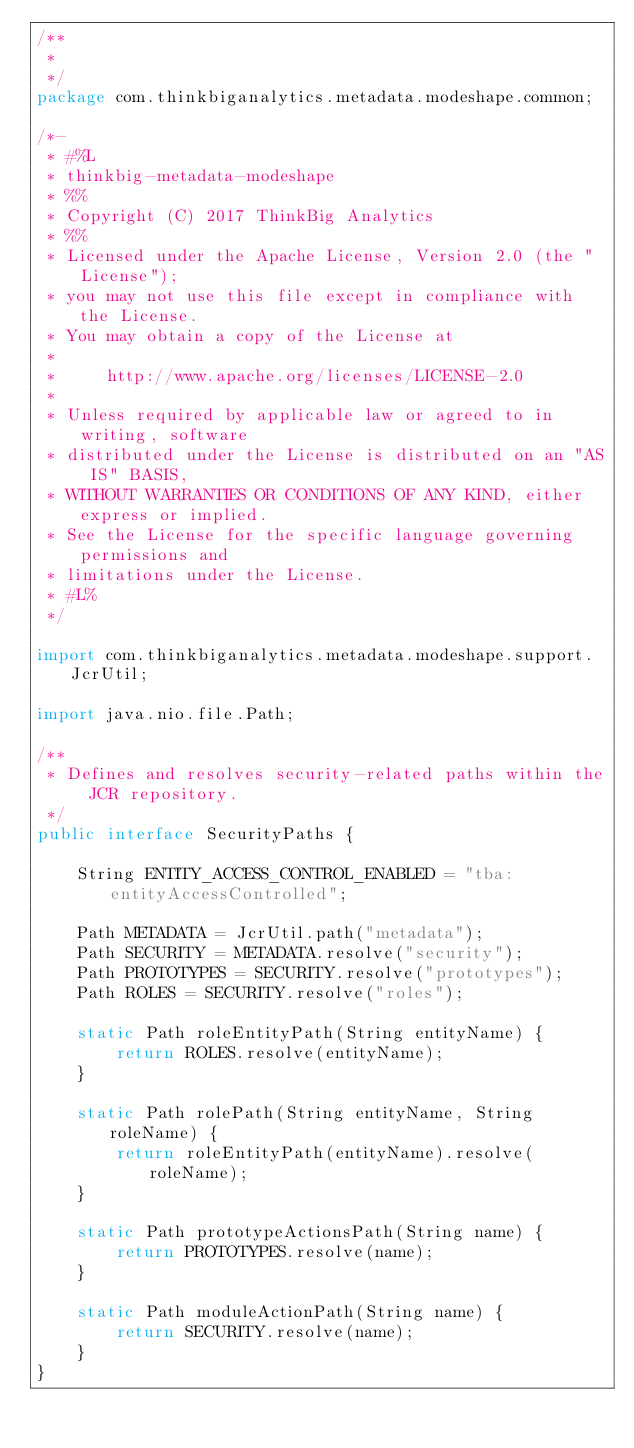<code> <loc_0><loc_0><loc_500><loc_500><_Java_>/**
 *
 */
package com.thinkbiganalytics.metadata.modeshape.common;

/*-
 * #%L
 * thinkbig-metadata-modeshape
 * %%
 * Copyright (C) 2017 ThinkBig Analytics
 * %%
 * Licensed under the Apache License, Version 2.0 (the "License");
 * you may not use this file except in compliance with the License.
 * You may obtain a copy of the License at
 * 
 *     http://www.apache.org/licenses/LICENSE-2.0
 * 
 * Unless required by applicable law or agreed to in writing, software
 * distributed under the License is distributed on an "AS IS" BASIS,
 * WITHOUT WARRANTIES OR CONDITIONS OF ANY KIND, either express or implied.
 * See the License for the specific language governing permissions and
 * limitations under the License.
 * #L%
 */

import com.thinkbiganalytics.metadata.modeshape.support.JcrUtil;

import java.nio.file.Path;

/**
 * Defines and resolves security-related paths within the JCR repository.
 */
public interface SecurityPaths {
    
    String ENTITY_ACCESS_CONTROL_ENABLED = "tba:entityAccessControlled";

    Path METADATA = JcrUtil.path("metadata");
    Path SECURITY = METADATA.resolve("security");
    Path PROTOTYPES = SECURITY.resolve("prototypes");
    Path ROLES = SECURITY.resolve("roles");
    
    static Path roleEntityPath(String entityName) {
        return ROLES.resolve(entityName);
    }
    
    static Path rolePath(String entityName, String roleName) {
        return roleEntityPath(entityName).resolve(roleName);
    }

    static Path prototypeActionsPath(String name) {
        return PROTOTYPES.resolve(name);
    }

    static Path moduleActionPath(String name) {
        return SECURITY.resolve(name);
    }
}
</code> 